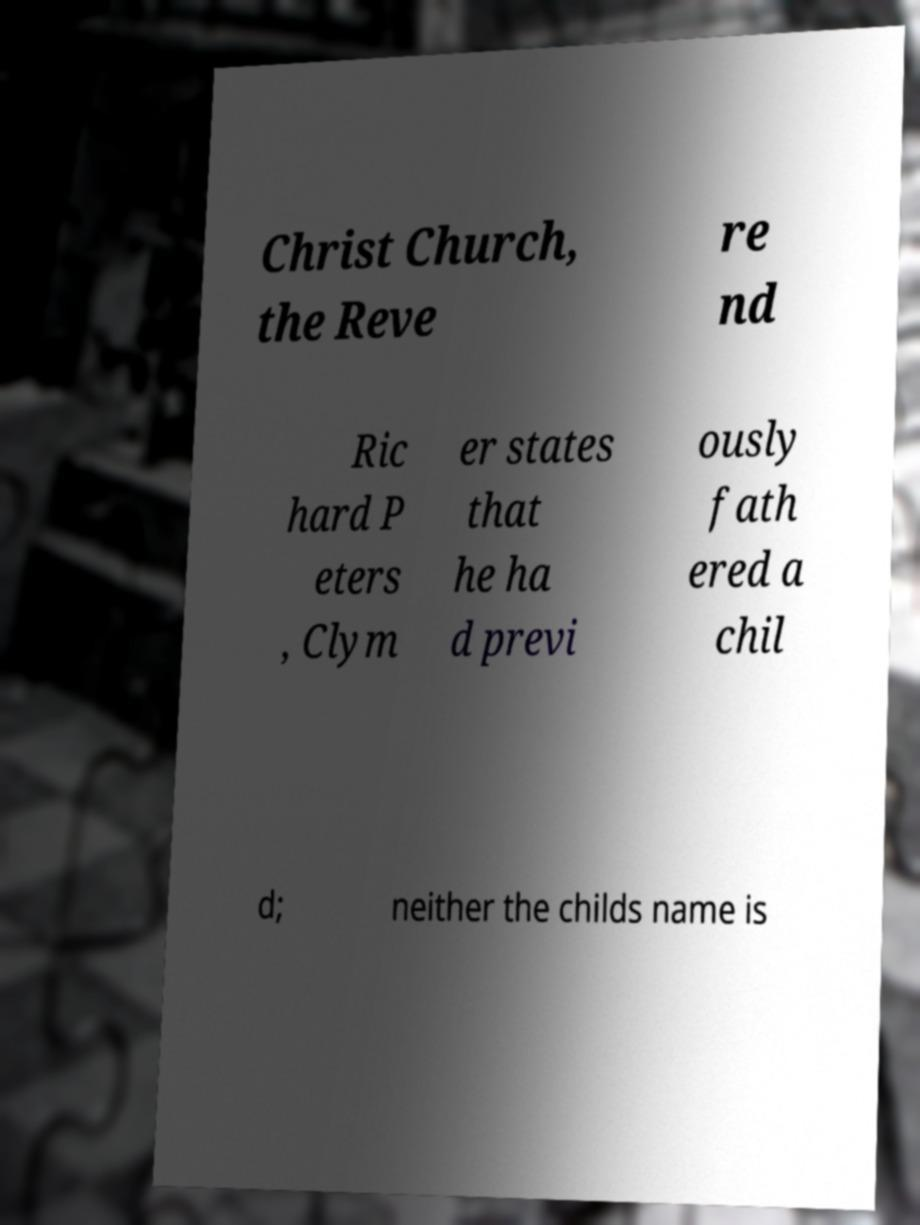There's text embedded in this image that I need extracted. Can you transcribe it verbatim? Christ Church, the Reve re nd Ric hard P eters , Clym er states that he ha d previ ously fath ered a chil d; neither the childs name is 